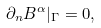Convert formula to latex. <formula><loc_0><loc_0><loc_500><loc_500>\partial _ { n } B ^ { \alpha } | _ { \Gamma } = 0 ,</formula> 